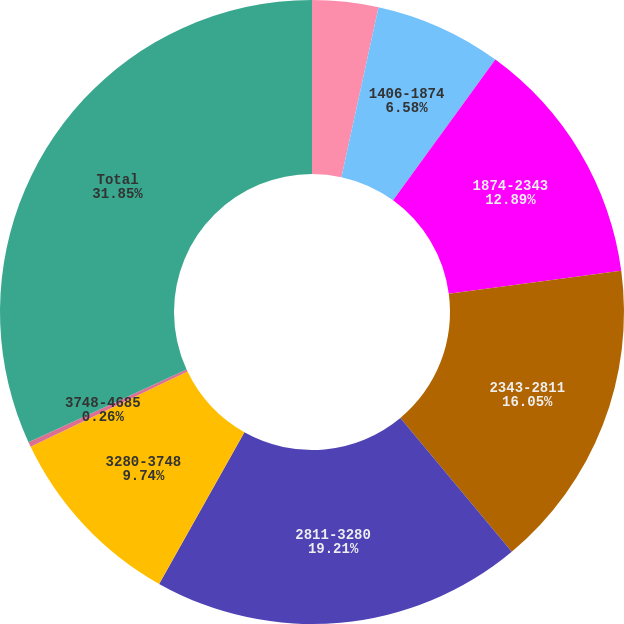Convert chart. <chart><loc_0><loc_0><loc_500><loc_500><pie_chart><fcel>937-1406<fcel>1406-1874<fcel>1874-2343<fcel>2343-2811<fcel>2811-3280<fcel>3280-3748<fcel>3748-4685<fcel>Total<nl><fcel>3.42%<fcel>6.58%<fcel>12.89%<fcel>16.05%<fcel>19.21%<fcel>9.74%<fcel>0.26%<fcel>31.85%<nl></chart> 